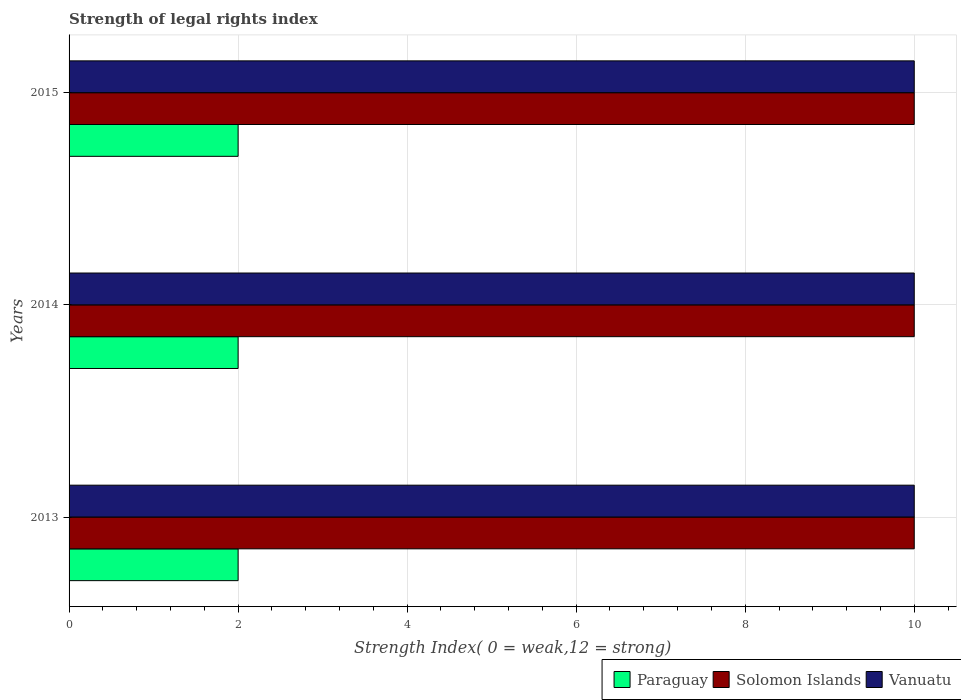How many different coloured bars are there?
Your answer should be compact. 3. Are the number of bars on each tick of the Y-axis equal?
Your answer should be very brief. Yes. What is the label of the 1st group of bars from the top?
Your answer should be very brief. 2015. What is the strength index in Paraguay in 2014?
Offer a very short reply. 2. Across all years, what is the maximum strength index in Vanuatu?
Offer a terse response. 10. Across all years, what is the minimum strength index in Solomon Islands?
Your answer should be very brief. 10. In which year was the strength index in Solomon Islands maximum?
Provide a short and direct response. 2013. In which year was the strength index in Paraguay minimum?
Give a very brief answer. 2013. What is the total strength index in Solomon Islands in the graph?
Ensure brevity in your answer.  30. What is the difference between the strength index in Paraguay in 2013 and the strength index in Solomon Islands in 2015?
Provide a short and direct response. -8. In the year 2013, what is the difference between the strength index in Paraguay and strength index in Solomon Islands?
Offer a terse response. -8. In how many years, is the strength index in Paraguay greater than 3.6 ?
Ensure brevity in your answer.  0. What is the ratio of the strength index in Vanuatu in 2013 to that in 2014?
Provide a succinct answer. 1. Is the strength index in Vanuatu in 2014 less than that in 2015?
Your response must be concise. No. What is the difference between the highest and the second highest strength index in Paraguay?
Your answer should be very brief. 0. What is the difference between the highest and the lowest strength index in Paraguay?
Provide a succinct answer. 0. In how many years, is the strength index in Paraguay greater than the average strength index in Paraguay taken over all years?
Your answer should be very brief. 0. Is the sum of the strength index in Vanuatu in 2013 and 2014 greater than the maximum strength index in Paraguay across all years?
Your answer should be very brief. Yes. What does the 1st bar from the top in 2014 represents?
Make the answer very short. Vanuatu. What does the 2nd bar from the bottom in 2015 represents?
Offer a very short reply. Solomon Islands. Is it the case that in every year, the sum of the strength index in Solomon Islands and strength index in Vanuatu is greater than the strength index in Paraguay?
Your answer should be very brief. Yes. Are all the bars in the graph horizontal?
Provide a short and direct response. Yes. Are the values on the major ticks of X-axis written in scientific E-notation?
Your answer should be compact. No. Does the graph contain any zero values?
Ensure brevity in your answer.  No. Does the graph contain grids?
Make the answer very short. Yes. What is the title of the graph?
Provide a short and direct response. Strength of legal rights index. Does "Central African Republic" appear as one of the legend labels in the graph?
Your answer should be very brief. No. What is the label or title of the X-axis?
Keep it short and to the point. Strength Index( 0 = weak,12 = strong). What is the Strength Index( 0 = weak,12 = strong) of Vanuatu in 2014?
Offer a terse response. 10. What is the Strength Index( 0 = weak,12 = strong) of Paraguay in 2015?
Your answer should be compact. 2. What is the Strength Index( 0 = weak,12 = strong) of Solomon Islands in 2015?
Your answer should be compact. 10. What is the Strength Index( 0 = weak,12 = strong) in Vanuatu in 2015?
Provide a short and direct response. 10. Across all years, what is the maximum Strength Index( 0 = weak,12 = strong) in Vanuatu?
Give a very brief answer. 10. Across all years, what is the minimum Strength Index( 0 = weak,12 = strong) in Paraguay?
Your response must be concise. 2. Across all years, what is the minimum Strength Index( 0 = weak,12 = strong) in Vanuatu?
Give a very brief answer. 10. What is the total Strength Index( 0 = weak,12 = strong) of Paraguay in the graph?
Offer a very short reply. 6. What is the total Strength Index( 0 = weak,12 = strong) of Solomon Islands in the graph?
Your answer should be compact. 30. What is the total Strength Index( 0 = weak,12 = strong) of Vanuatu in the graph?
Offer a terse response. 30. What is the difference between the Strength Index( 0 = weak,12 = strong) of Paraguay in 2013 and that in 2014?
Your answer should be compact. 0. What is the difference between the Strength Index( 0 = weak,12 = strong) in Solomon Islands in 2013 and that in 2014?
Offer a terse response. 0. What is the difference between the Strength Index( 0 = weak,12 = strong) of Vanuatu in 2013 and that in 2014?
Your response must be concise. 0. What is the difference between the Strength Index( 0 = weak,12 = strong) of Paraguay in 2014 and that in 2015?
Offer a very short reply. 0. What is the difference between the Strength Index( 0 = weak,12 = strong) of Solomon Islands in 2014 and that in 2015?
Give a very brief answer. 0. What is the difference between the Strength Index( 0 = weak,12 = strong) in Vanuatu in 2014 and that in 2015?
Make the answer very short. 0. What is the difference between the Strength Index( 0 = weak,12 = strong) of Paraguay in 2013 and the Strength Index( 0 = weak,12 = strong) of Solomon Islands in 2014?
Provide a short and direct response. -8. What is the difference between the Strength Index( 0 = weak,12 = strong) in Paraguay in 2013 and the Strength Index( 0 = weak,12 = strong) in Solomon Islands in 2015?
Ensure brevity in your answer.  -8. What is the difference between the Strength Index( 0 = weak,12 = strong) in Paraguay in 2013 and the Strength Index( 0 = weak,12 = strong) in Vanuatu in 2015?
Keep it short and to the point. -8. What is the difference between the Strength Index( 0 = weak,12 = strong) of Solomon Islands in 2013 and the Strength Index( 0 = weak,12 = strong) of Vanuatu in 2015?
Provide a succinct answer. 0. What is the difference between the Strength Index( 0 = weak,12 = strong) of Paraguay in 2014 and the Strength Index( 0 = weak,12 = strong) of Solomon Islands in 2015?
Make the answer very short. -8. What is the difference between the Strength Index( 0 = weak,12 = strong) of Solomon Islands in 2014 and the Strength Index( 0 = weak,12 = strong) of Vanuatu in 2015?
Provide a succinct answer. 0. What is the average Strength Index( 0 = weak,12 = strong) of Paraguay per year?
Give a very brief answer. 2. In the year 2013, what is the difference between the Strength Index( 0 = weak,12 = strong) of Solomon Islands and Strength Index( 0 = weak,12 = strong) of Vanuatu?
Ensure brevity in your answer.  0. In the year 2014, what is the difference between the Strength Index( 0 = weak,12 = strong) in Paraguay and Strength Index( 0 = weak,12 = strong) in Solomon Islands?
Your answer should be compact. -8. In the year 2014, what is the difference between the Strength Index( 0 = weak,12 = strong) of Paraguay and Strength Index( 0 = weak,12 = strong) of Vanuatu?
Your response must be concise. -8. In the year 2015, what is the difference between the Strength Index( 0 = weak,12 = strong) of Paraguay and Strength Index( 0 = weak,12 = strong) of Solomon Islands?
Give a very brief answer. -8. In the year 2015, what is the difference between the Strength Index( 0 = weak,12 = strong) of Paraguay and Strength Index( 0 = weak,12 = strong) of Vanuatu?
Make the answer very short. -8. In the year 2015, what is the difference between the Strength Index( 0 = weak,12 = strong) of Solomon Islands and Strength Index( 0 = weak,12 = strong) of Vanuatu?
Provide a succinct answer. 0. What is the ratio of the Strength Index( 0 = weak,12 = strong) in Solomon Islands in 2013 to that in 2014?
Make the answer very short. 1. What is the ratio of the Strength Index( 0 = weak,12 = strong) in Solomon Islands in 2013 to that in 2015?
Your answer should be compact. 1. What is the ratio of the Strength Index( 0 = weak,12 = strong) of Vanuatu in 2013 to that in 2015?
Your response must be concise. 1. What is the ratio of the Strength Index( 0 = weak,12 = strong) in Paraguay in 2014 to that in 2015?
Offer a very short reply. 1. What is the ratio of the Strength Index( 0 = weak,12 = strong) in Solomon Islands in 2014 to that in 2015?
Offer a very short reply. 1. What is the ratio of the Strength Index( 0 = weak,12 = strong) of Vanuatu in 2014 to that in 2015?
Provide a succinct answer. 1. What is the difference between the highest and the lowest Strength Index( 0 = weak,12 = strong) of Solomon Islands?
Provide a succinct answer. 0. 